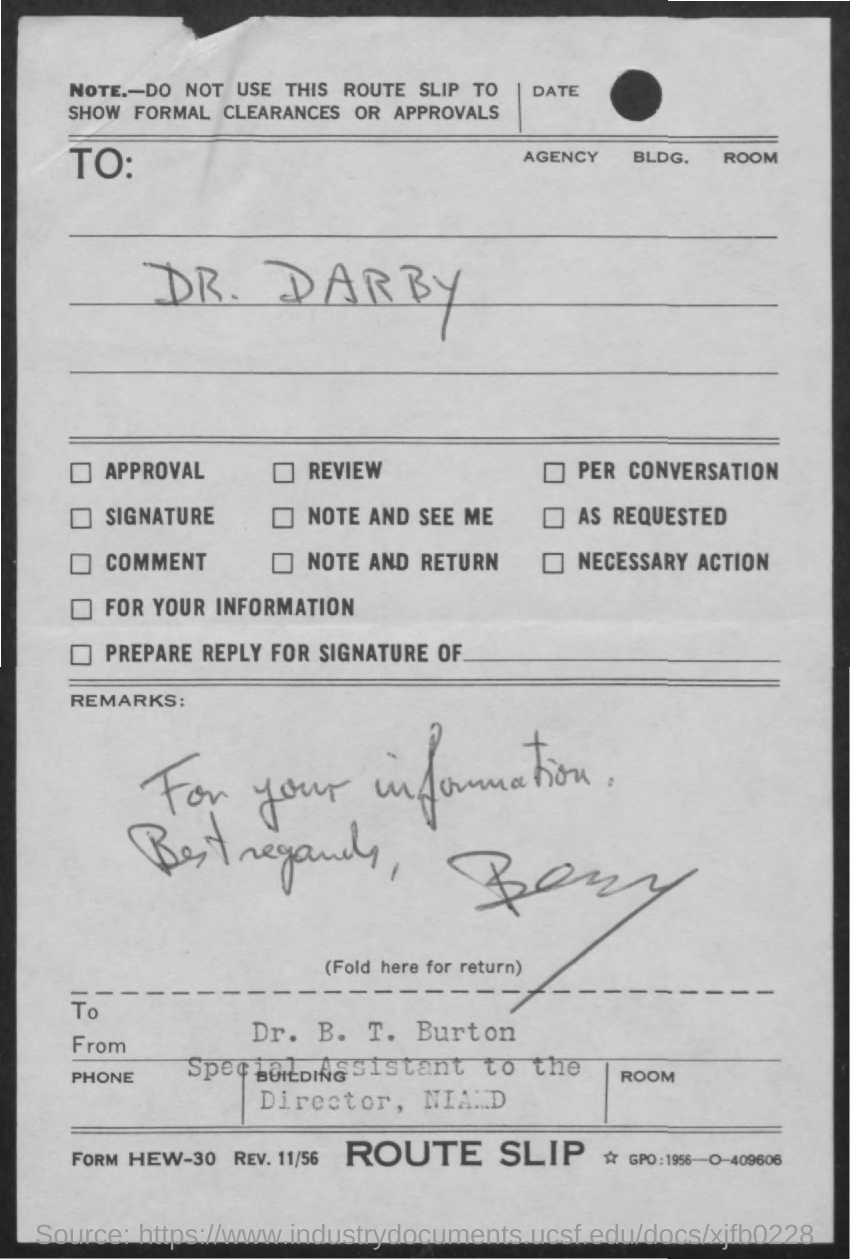To Whom is this letter addressed to?
Offer a very short reply. DR. DARBY. Who is this letter from?
Your answer should be compact. DR. B. T. BURTON. 